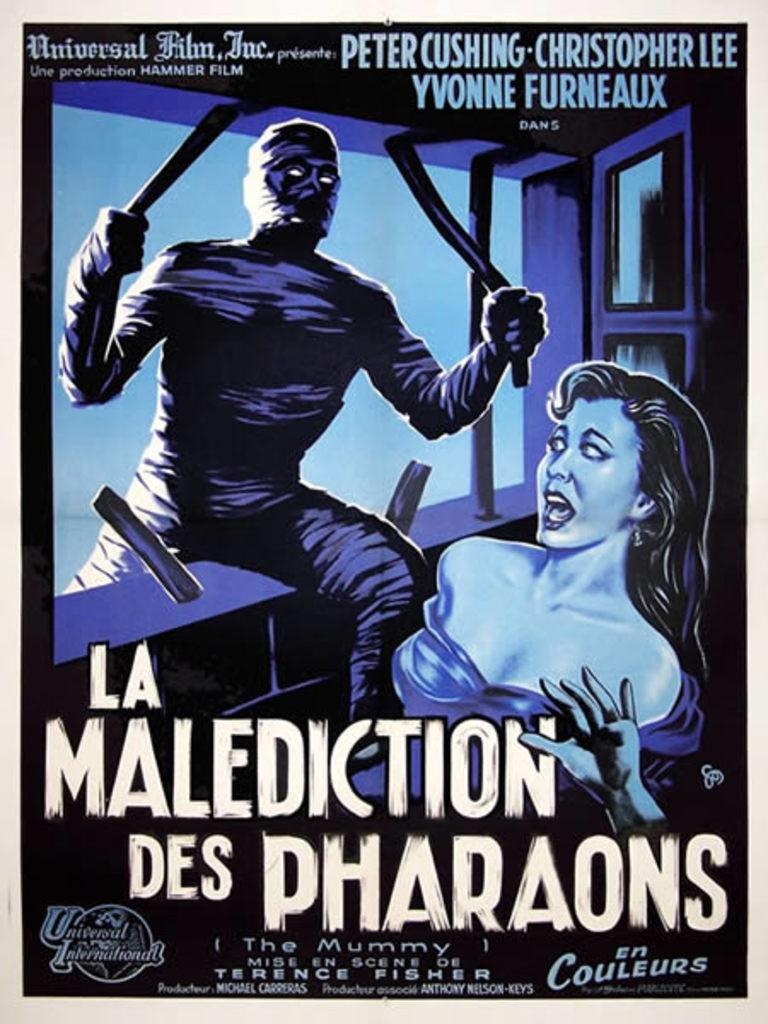<image>
Share a concise interpretation of the image provided. An old Christopher Lee movie poster that has a monster approaching a woman. 